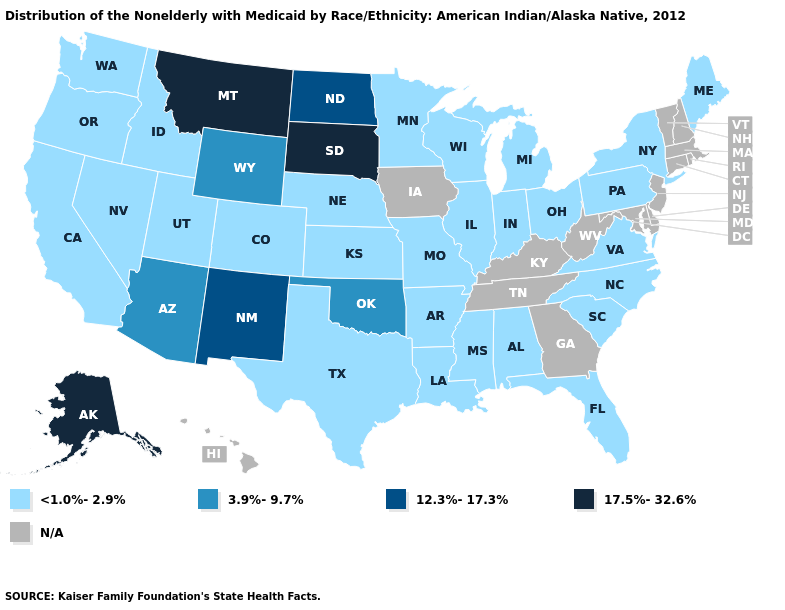Name the states that have a value in the range N/A?
Quick response, please. Connecticut, Delaware, Georgia, Hawaii, Iowa, Kentucky, Maryland, Massachusetts, New Hampshire, New Jersey, Rhode Island, Tennessee, Vermont, West Virginia. Name the states that have a value in the range N/A?
Short answer required. Connecticut, Delaware, Georgia, Hawaii, Iowa, Kentucky, Maryland, Massachusetts, New Hampshire, New Jersey, Rhode Island, Tennessee, Vermont, West Virginia. Does Idaho have the lowest value in the USA?
Answer briefly. Yes. Which states hav the highest value in the South?
Concise answer only. Oklahoma. Does Wisconsin have the lowest value in the MidWest?
Give a very brief answer. Yes. What is the highest value in the MidWest ?
Answer briefly. 17.5%-32.6%. What is the value of Oregon?
Give a very brief answer. <1.0%-2.9%. Name the states that have a value in the range <1.0%-2.9%?
Give a very brief answer. Alabama, Arkansas, California, Colorado, Florida, Idaho, Illinois, Indiana, Kansas, Louisiana, Maine, Michigan, Minnesota, Mississippi, Missouri, Nebraska, Nevada, New York, North Carolina, Ohio, Oregon, Pennsylvania, South Carolina, Texas, Utah, Virginia, Washington, Wisconsin. What is the value of Oklahoma?
Write a very short answer. 3.9%-9.7%. What is the value of New York?
Concise answer only. <1.0%-2.9%. Does New Mexico have the lowest value in the USA?
Concise answer only. No. Which states have the lowest value in the West?
Write a very short answer. California, Colorado, Idaho, Nevada, Oregon, Utah, Washington. Name the states that have a value in the range <1.0%-2.9%?
Be succinct. Alabama, Arkansas, California, Colorado, Florida, Idaho, Illinois, Indiana, Kansas, Louisiana, Maine, Michigan, Minnesota, Mississippi, Missouri, Nebraska, Nevada, New York, North Carolina, Ohio, Oregon, Pennsylvania, South Carolina, Texas, Utah, Virginia, Washington, Wisconsin. Which states have the highest value in the USA?
Write a very short answer. Alaska, Montana, South Dakota. 